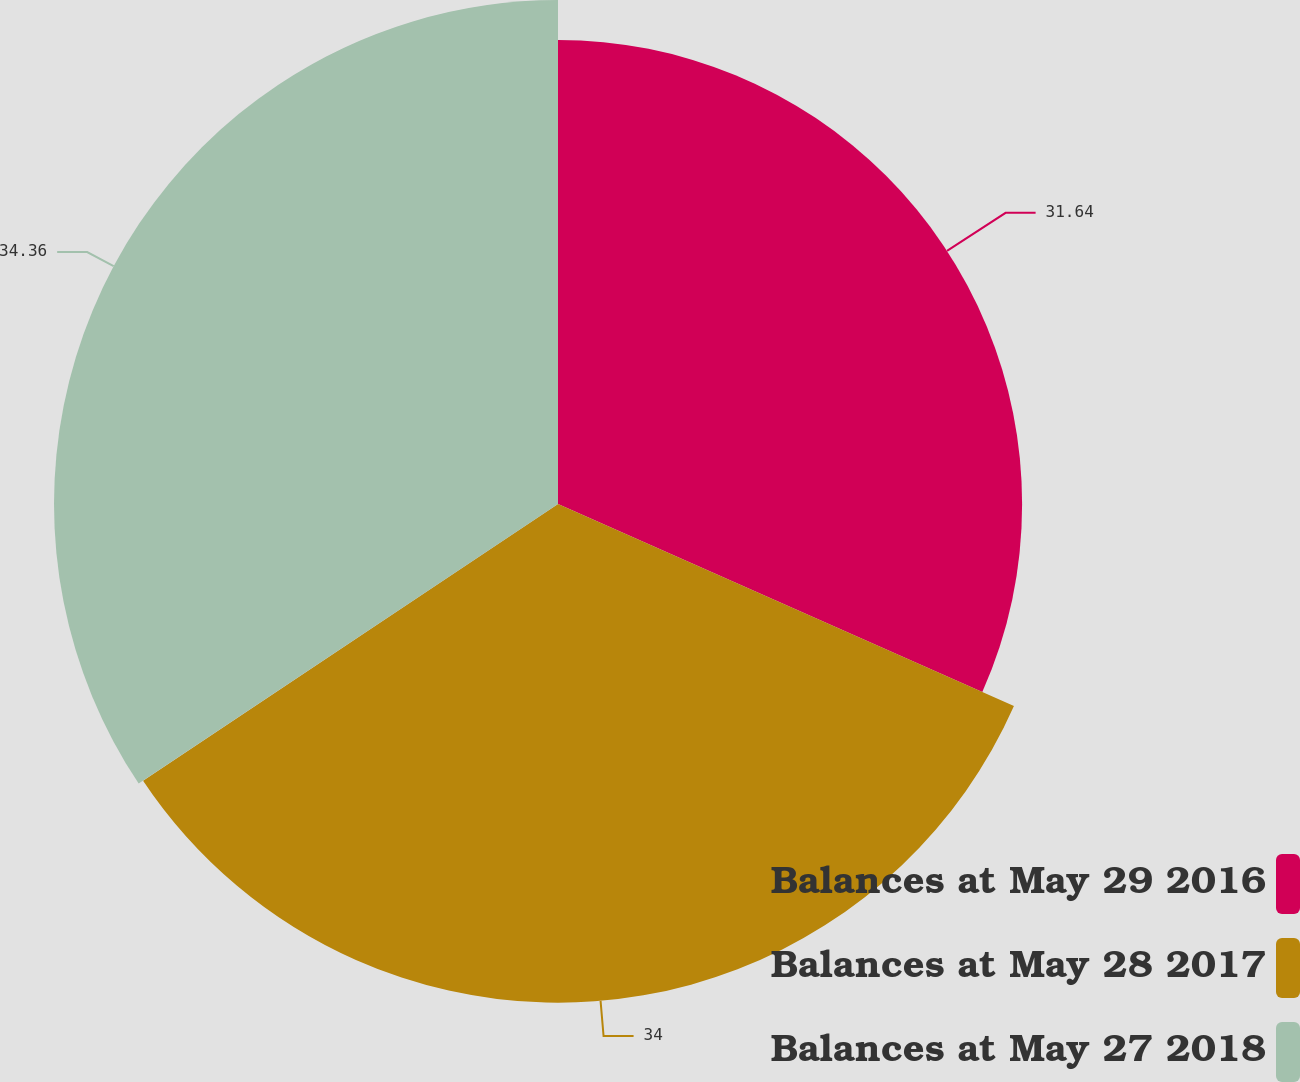Convert chart. <chart><loc_0><loc_0><loc_500><loc_500><pie_chart><fcel>Balances at May 29 2016<fcel>Balances at May 28 2017<fcel>Balances at May 27 2018<nl><fcel>31.64%<fcel>34.0%<fcel>34.36%<nl></chart> 